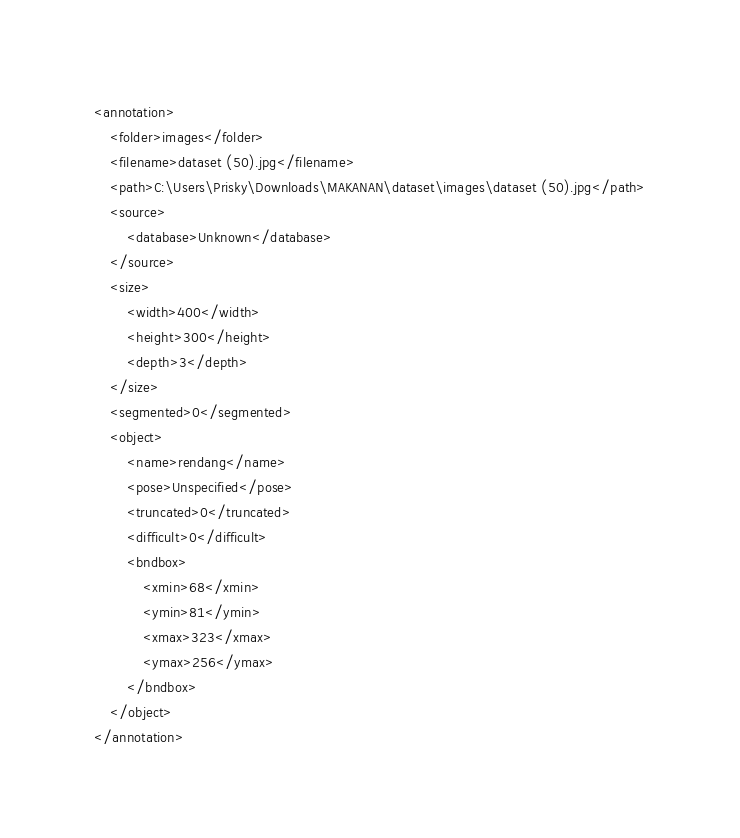<code> <loc_0><loc_0><loc_500><loc_500><_XML_><annotation>
	<folder>images</folder>
	<filename>dataset (50).jpg</filename>
	<path>C:\Users\Prisky\Downloads\MAKANAN\dataset\images\dataset (50).jpg</path>
	<source>
		<database>Unknown</database>
	</source>
	<size>
		<width>400</width>
		<height>300</height>
		<depth>3</depth>
	</size>
	<segmented>0</segmented>
	<object>
		<name>rendang</name>
		<pose>Unspecified</pose>
		<truncated>0</truncated>
		<difficult>0</difficult>
		<bndbox>
			<xmin>68</xmin>
			<ymin>81</ymin>
			<xmax>323</xmax>
			<ymax>256</ymax>
		</bndbox>
	</object>
</annotation>
</code> 